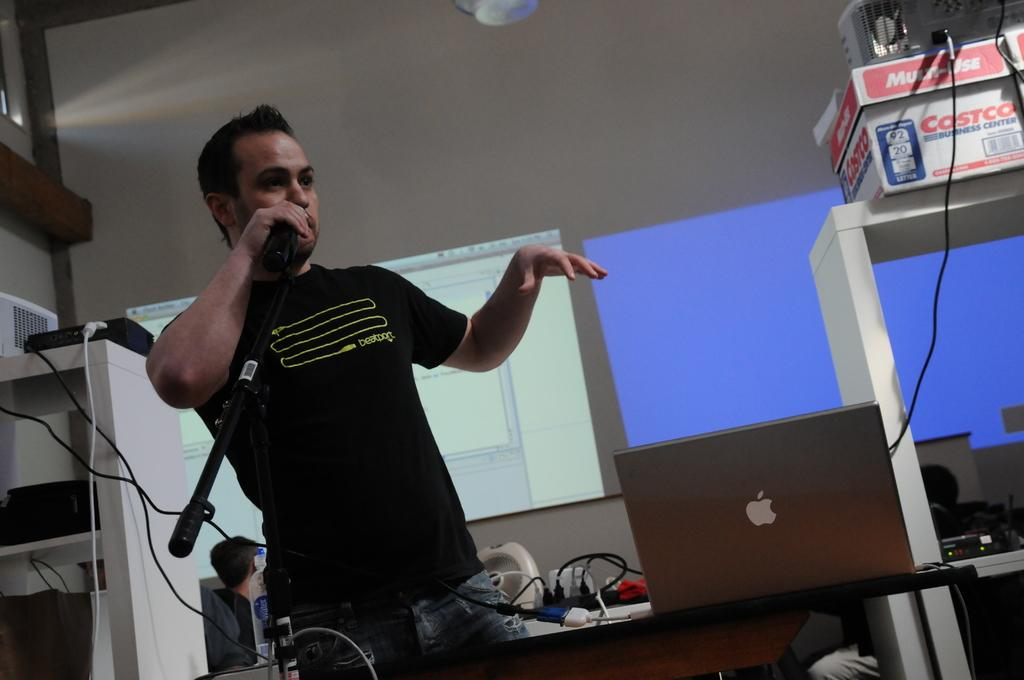What can be seen in the foreground of the image? In the foreground of the image, there are cables, a person, a mic, a table, and electronic gadgets. What is the person in the foreground doing? The person in the foreground is not performing any specific action that can be determined from the image. What is the purpose of the mic in the foreground? The purpose of the mic in the foreground is not clear from the image. What is the main object in the background of the image? In the background of the image, there is a projector screen and a wall. Can you describe the person in the background of the image? The person in the background of the image is not performing any specific action that can be determined from the image. How many slaves are visible in the image? There are no slaves present in the image. What type of horse can be seen in the background of the image? There are no horses present in the image. 